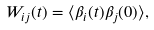<formula> <loc_0><loc_0><loc_500><loc_500>W _ { i j } ( t ) = \langle \beta _ { i } ( t ) \beta _ { j } ( 0 ) \rangle ,</formula> 